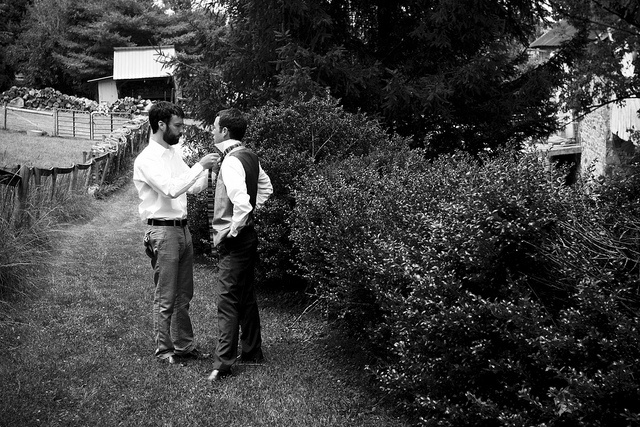Describe the objects in this image and their specific colors. I can see people in black, white, gray, and darkgray tones, people in black, white, gray, and darkgray tones, tie in black, gray, darkgray, and lightgray tones, and tie in black, gray, white, and darkgray tones in this image. 